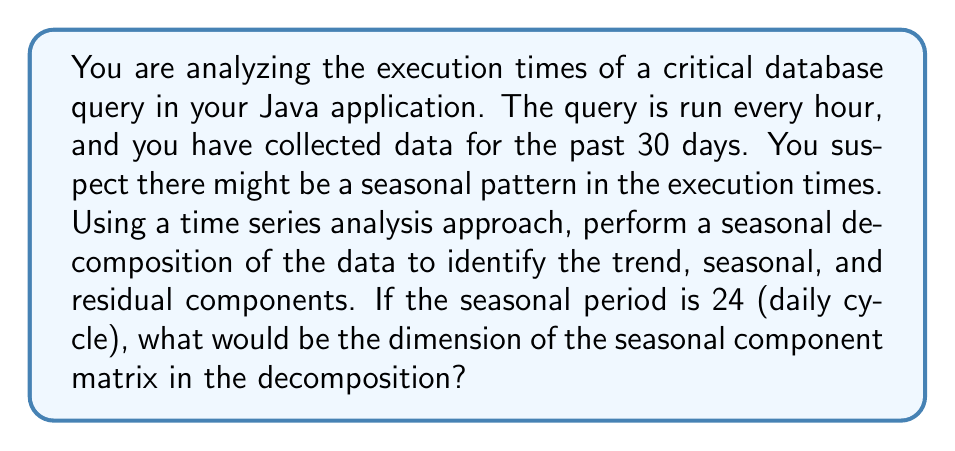Provide a solution to this math problem. To approach this problem, we need to understand the concept of seasonal decomposition in time series analysis and how it applies to our database query execution times.

1. Time series components:
   A time series can be decomposed into three main components:
   - Trend (T): The long-term progression of the series
   - Seasonal (S): Repeating patterns or cycles of fixed length
   - Residual (R): The random variation in the series

2. Seasonal decomposition:
   The process of breaking down a time series into these components is called seasonal decomposition. The most common model is the additive model:

   $$Y_t = T_t + S_t + R_t$$

   Where $Y_t$ is the observed value at time t.

3. Data structure:
   - We have hourly data for 30 days
   - Total number of observations = 24 hours/day * 30 days = 720 observations

4. Seasonal period:
   - Given seasonal period is 24 (daily cycle)

5. Seasonal component matrix:
   - In seasonal decomposition, the seasonal component is represented as a matrix
   - The number of rows in this matrix is equal to the seasonal period
   - The number of columns is equal to the number of complete cycles in the data

6. Calculating the dimension:
   - Rows = Seasonal period = 24
   - Columns = Number of complete cycles = Total observations / Seasonal period
   - Columns = 720 / 24 = 30

Therefore, the dimension of the seasonal component matrix would be 24 x 30.

This approach allows us to isolate and analyze the daily patterns in query execution times, which could be valuable for optimizing database performance in a Java application.
Answer: The dimension of the seasonal component matrix in the decomposition would be 24 x 30. 